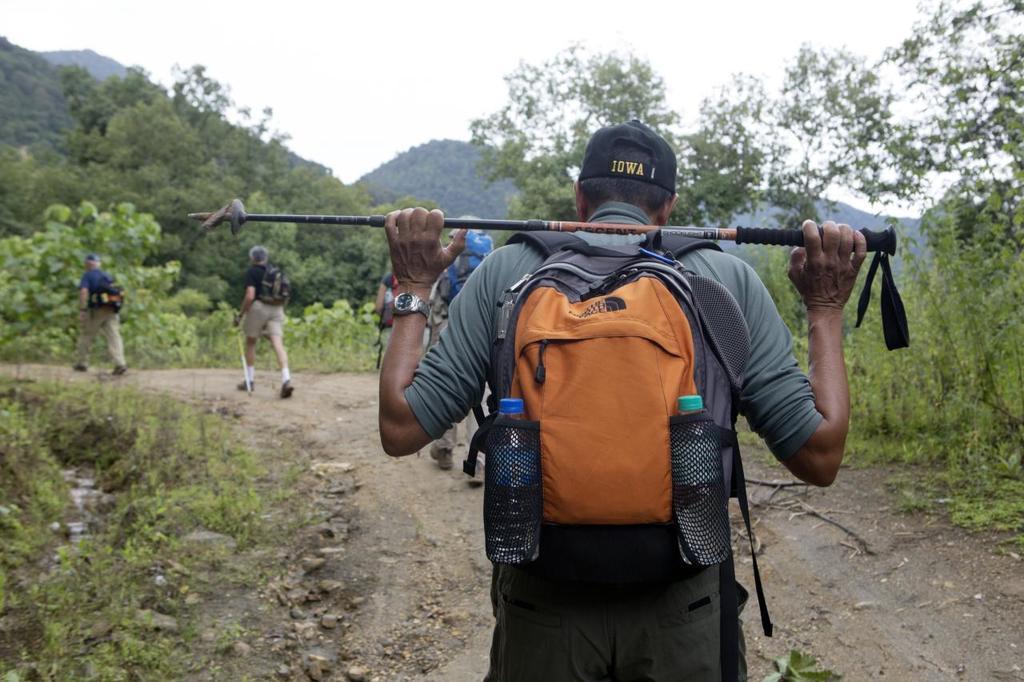What is on his hat?
Provide a succinct answer. Iowa. What is the brand of orange backpack?
Provide a short and direct response. The north face. 